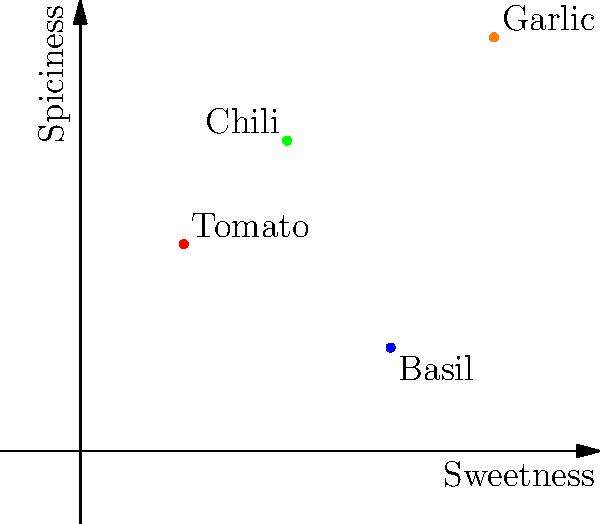In this flavor profile coordinate plane, where sweetness is represented on the x-axis and spiciness on the y-axis, four common ingredients are plotted: tomato (1,2), basil (3,1), chili (2,3), and garlic (4,4). Which ingredient would you recommend to add more complexity to a dish that's currently too sweet and lacks heat? To answer this question, we need to analyze the flavor profile of each ingredient based on their position in the coordinate plane:

1. Tomato (1,2): Low sweetness, moderate spiciness
2. Basil (3,1): Moderate sweetness, low spiciness
3. Chili (2,3): Moderate sweetness, high spiciness
4. Garlic (4,4): High sweetness, high spiciness

The question asks for an ingredient to balance a dish that's too sweet and lacks heat. We need an ingredient that's less sweet and more spicy. Looking at the coordinates:

- Tomato has low sweetness, which could help reduce overall sweetness, and moderate spiciness to add some heat.
- Basil has moderate sweetness and low spiciness, which won't help much in this case.
- Chili has moderate sweetness and high spiciness, which could add significant heat but may not reduce sweetness enough.
- Garlic has high sweetness and high spiciness, which would increase both sweetness and heat.

Among these options, chili would be the best choice to add more complexity by significantly increasing the heat while not adding too much sweetness. Tomato could be a second choice, but it wouldn't add as much heat as chili.
Answer: Chili 